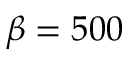Convert formula to latex. <formula><loc_0><loc_0><loc_500><loc_500>\beta = 5 0 0</formula> 